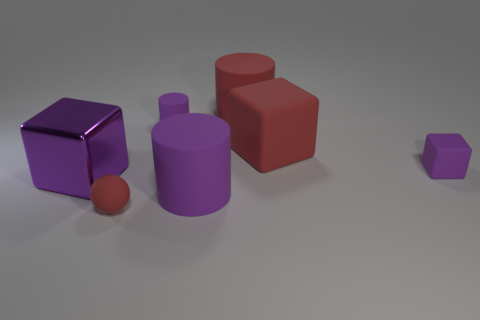Add 2 big metal objects. How many objects exist? 9 Subtract all cylinders. How many objects are left? 4 Add 6 large red matte things. How many large red matte things are left? 8 Add 7 tiny gray matte things. How many tiny gray matte things exist? 7 Subtract 0 cyan cylinders. How many objects are left? 7 Subtract all yellow rubber spheres. Subtract all big purple cubes. How many objects are left? 6 